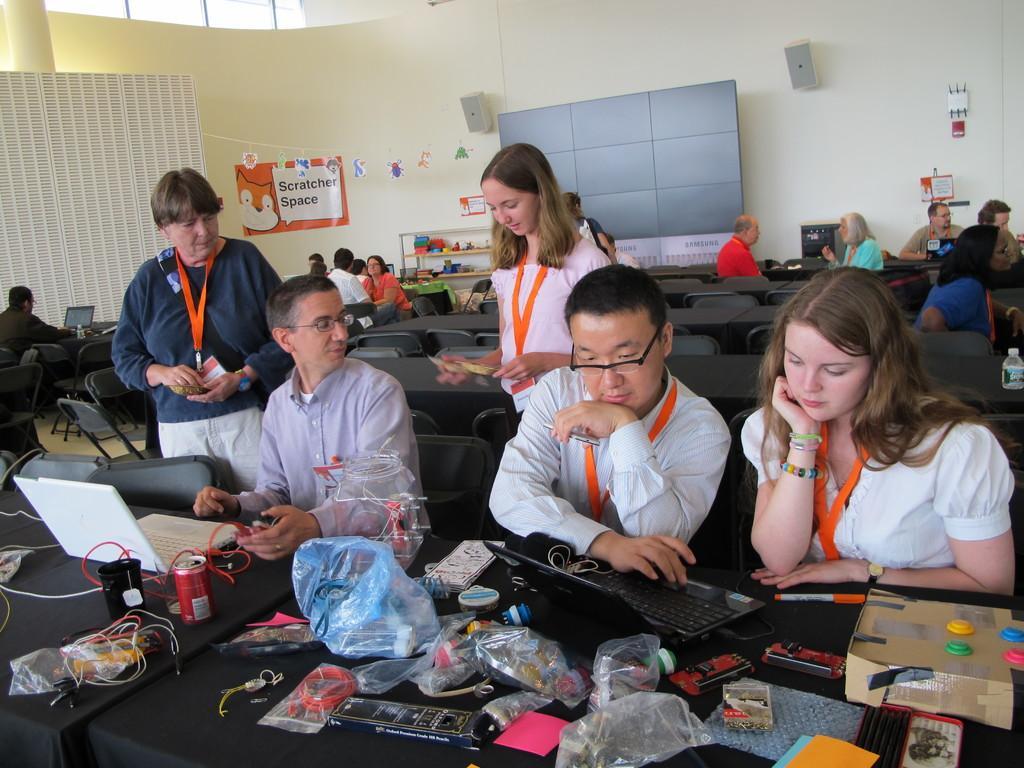How would you summarize this image in a sentence or two? In this image I can see group of people, some are sitting and some are standing and I can see two laptops, few covers, cardboard boxes on the table. In the background I can see the banner attached to the wall and the wall is in cream color. 